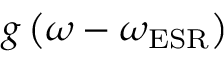Convert formula to latex. <formula><loc_0><loc_0><loc_500><loc_500>g \left ( \omega - \omega _ { E S R } \right )</formula> 